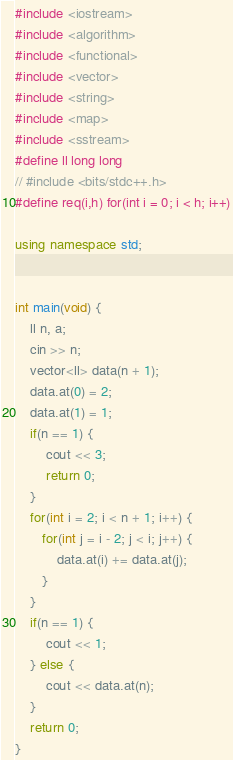<code> <loc_0><loc_0><loc_500><loc_500><_C++_>#include <iostream>
#include <algorithm>
#include <functional>
#include <vector>
#include <string>
#include <map>
#include <sstream>
#define ll long long
// #include <bits/stdc++.h>
#define req(i,h) for(int i = 0; i < h; i++)

using namespace std;


int main(void) {
    ll n, a;
    cin >> n;
    vector<ll> data(n + 1);
    data.at(0) = 2;
    data.at(1) = 1;
    if(n == 1) {
        cout << 3;
        return 0;
    }
    for(int i = 2; i < n + 1; i++) {
       for(int j = i - 2; j < i; j++) {
           data.at(i) += data.at(j);
       }
    }
    if(n == 1) {
        cout << 1;
    } else {
        cout << data.at(n);
    }
    return 0;
}
</code> 